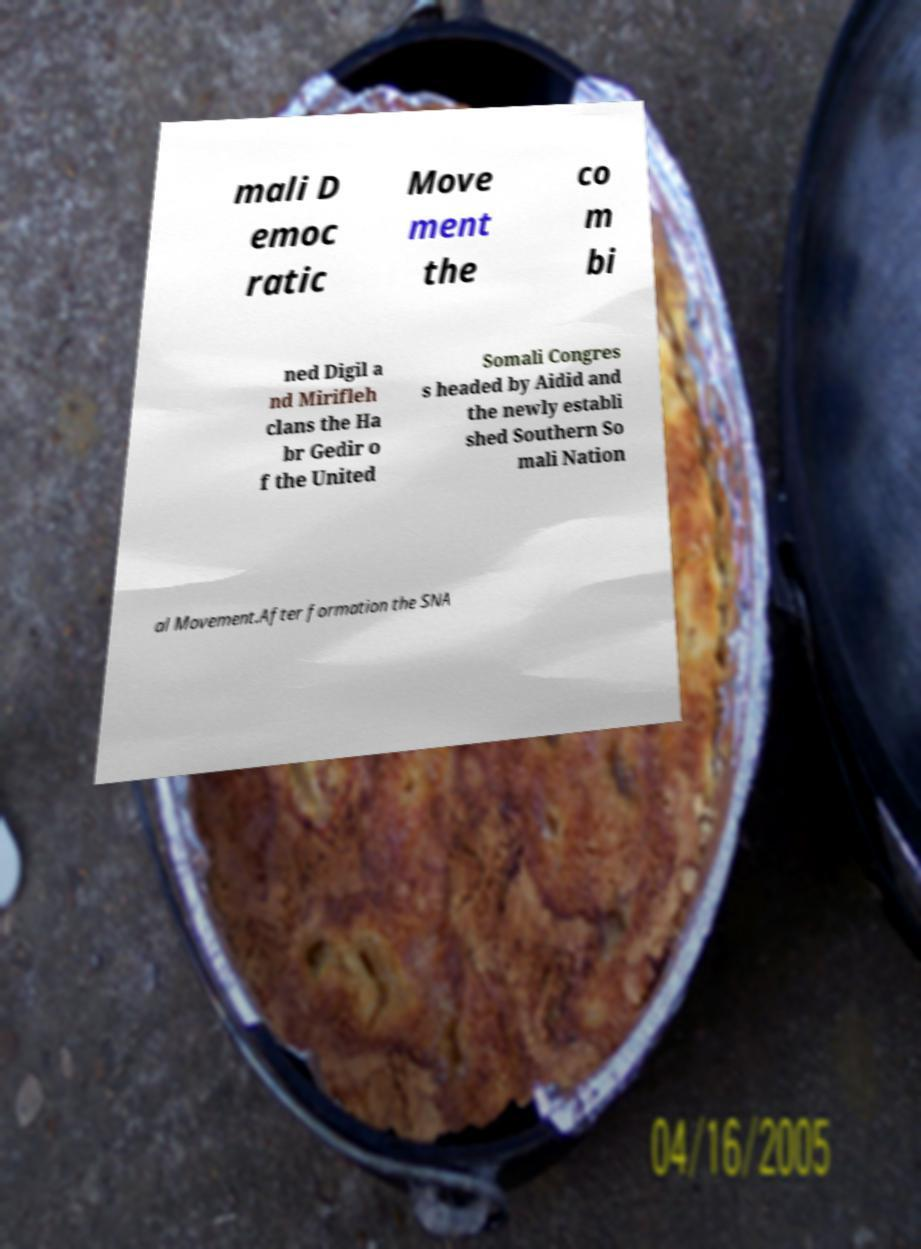I need the written content from this picture converted into text. Can you do that? mali D emoc ratic Move ment the co m bi ned Digil a nd Mirifleh clans the Ha br Gedir o f the United Somali Congres s headed by Aidid and the newly establi shed Southern So mali Nation al Movement.After formation the SNA 